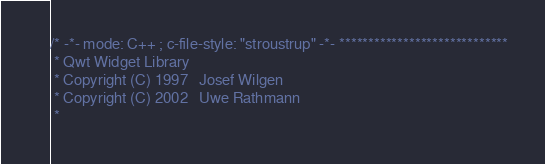Convert code to text. <code><loc_0><loc_0><loc_500><loc_500><_C++_>/* -*- mode: C++ ; c-file-style: "stroustrup" -*- *****************************
 * Qwt Widget Library
 * Copyright (C) 1997   Josef Wilgen
 * Copyright (C) 2002   Uwe Rathmann
 *</code> 